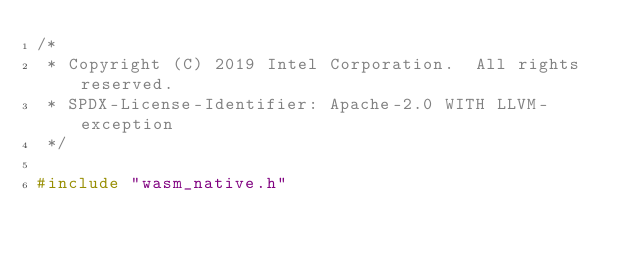Convert code to text. <code><loc_0><loc_0><loc_500><loc_500><_C_>/*
 * Copyright (C) 2019 Intel Corporation.  All rights reserved.
 * SPDX-License-Identifier: Apache-2.0 WITH LLVM-exception
 */

#include "wasm_native.h"</code> 